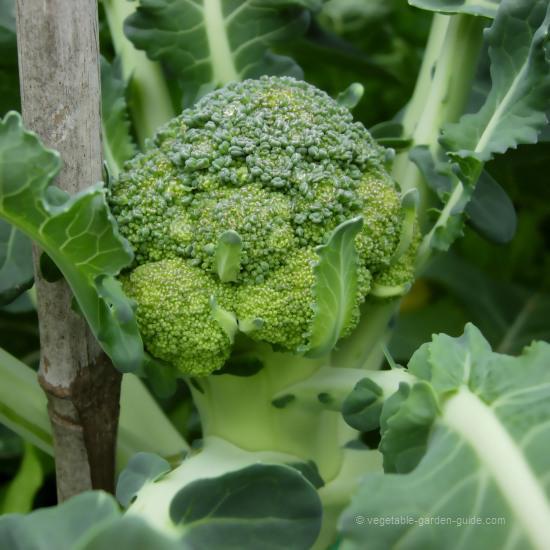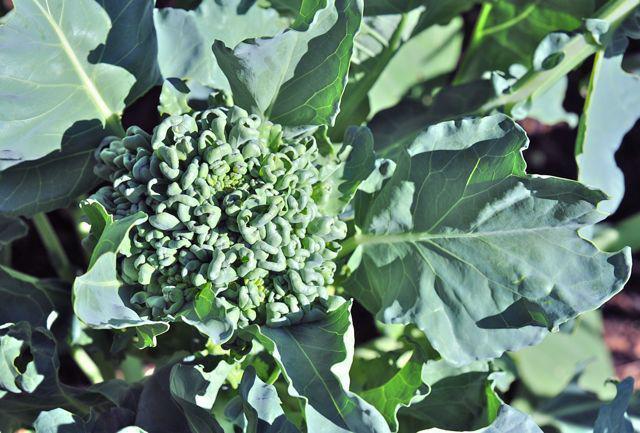The first image is the image on the left, the second image is the image on the right. Examine the images to the left and right. Is the description "The left and right image contains the same number of head of broccoli." accurate? Answer yes or no. Yes. The first image is the image on the left, the second image is the image on the right. Examine the images to the left and right. Is the description "There are three separate broccoli branches." accurate? Answer yes or no. No. 